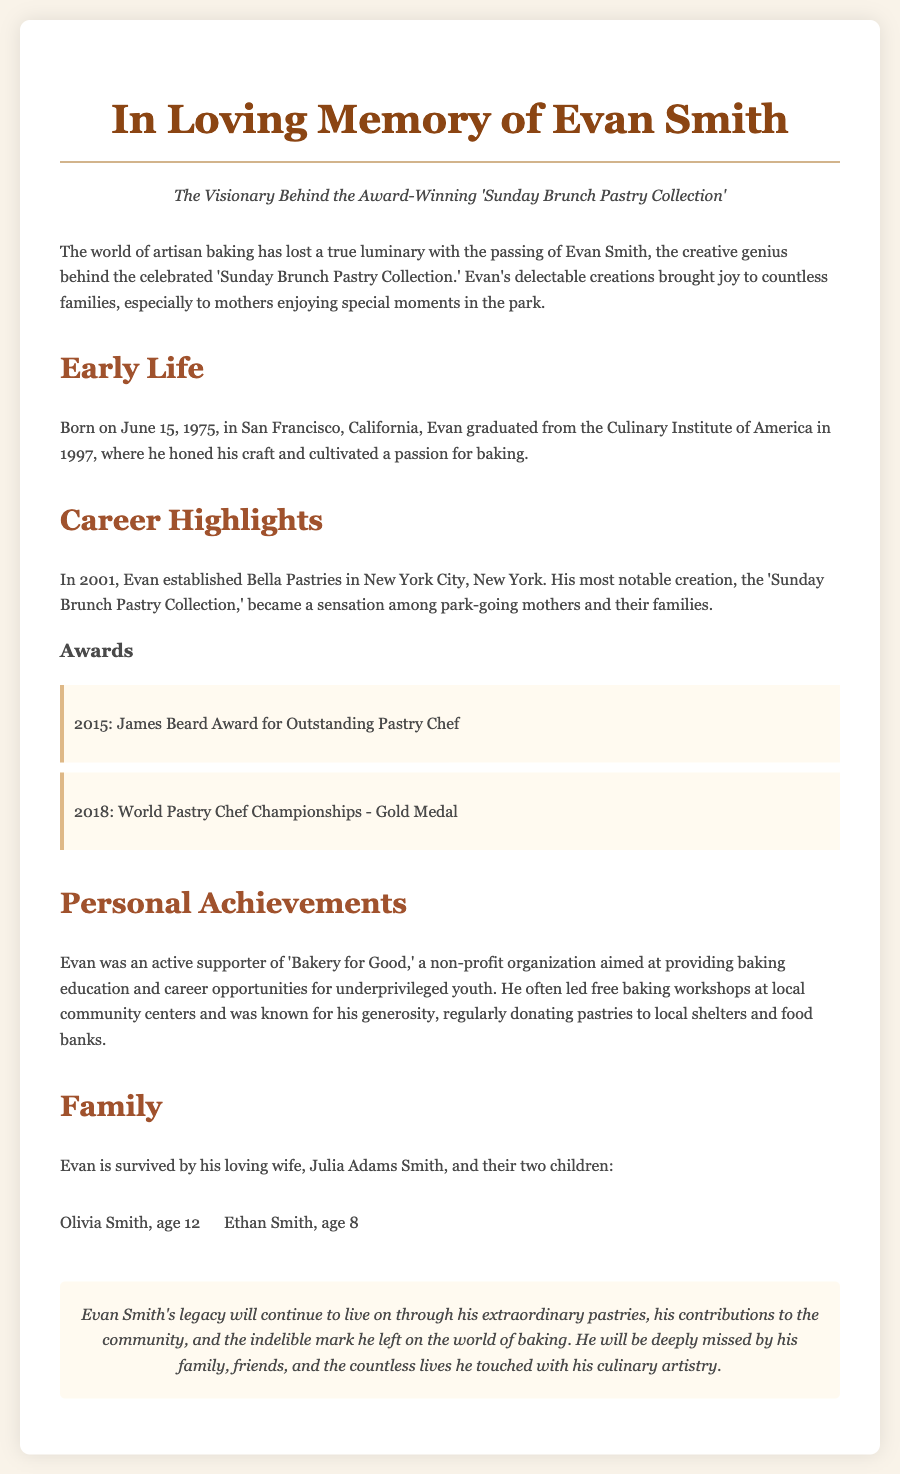What is the name of the pastry collection? The pastry collection is called the 'Sunday Brunch Pastry Collection.'
Answer: 'Sunday Brunch Pastry Collection' When was Evan Smith born? Evan Smith was born on June 15, 1975.
Answer: June 15, 1975 Which award did Evan receive in 2015? The award Evan received in 2015 was the James Beard Award for Outstanding Pastry Chef.
Answer: James Beard Award for Outstanding Pastry Chef What organization did Evan support? Evan was an active supporter of 'Bakery for Good.'
Answer: Bakery for Good How many children did Evan have? Evan had two children.
Answer: Two What city did Evan establish Bella Pastries? Bella Pastries was established in New York City.
Answer: New York City What was Evan's profession? Evan was a pastry chef.
Answer: Pastry chef What was one of Evan's personal contributions? Evan led free baking workshops at local community centers.
Answer: Led free baking workshops Who survives Evan the obituary mentions? Evan is survived by his wife, Julia Adams Smith.
Answer: Julia Adams Smith 